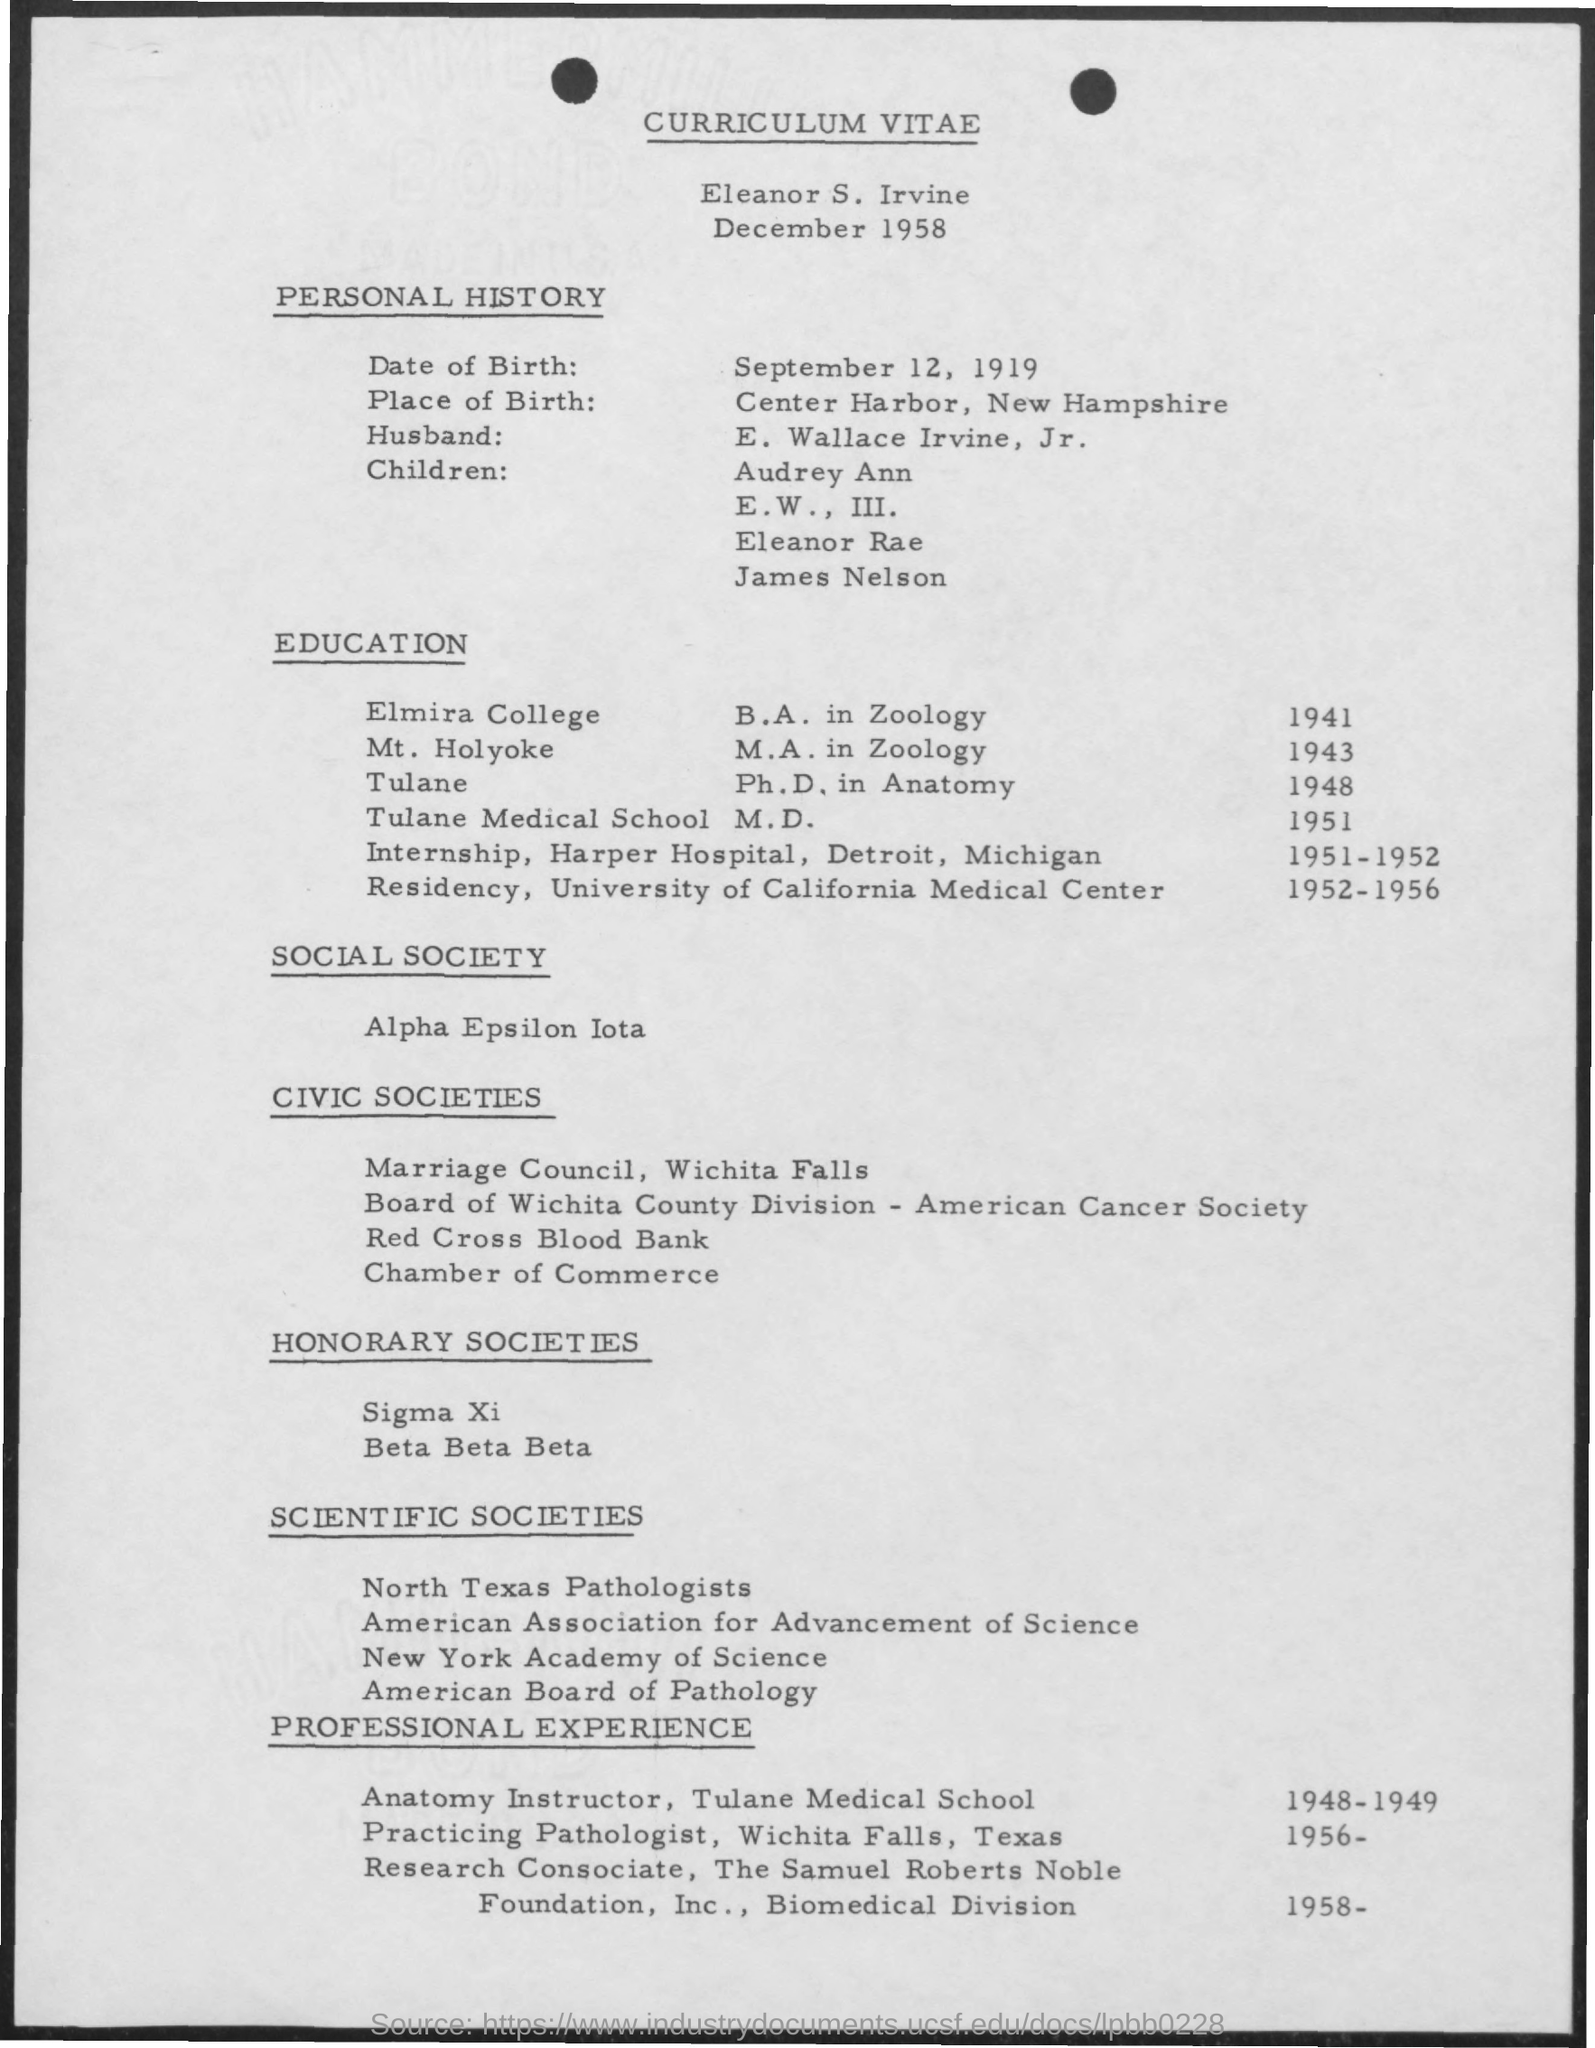What is the date of birth mentioned in the given page ?
Your answer should be compact. September 12, 1919. What is the place of birth mentioned in the given page ?
Make the answer very short. Center harbor , new hampshire. What is the name of the husband mentioned ?
Ensure brevity in your answer.  E. WALLACE IRVINE, JR. What is the name of the social society mentioned ?
Offer a terse response. ALPHA EPSILON IOTA. What is the name of the college in which b.a. is completed ?
Make the answer very short. Elmira college. 